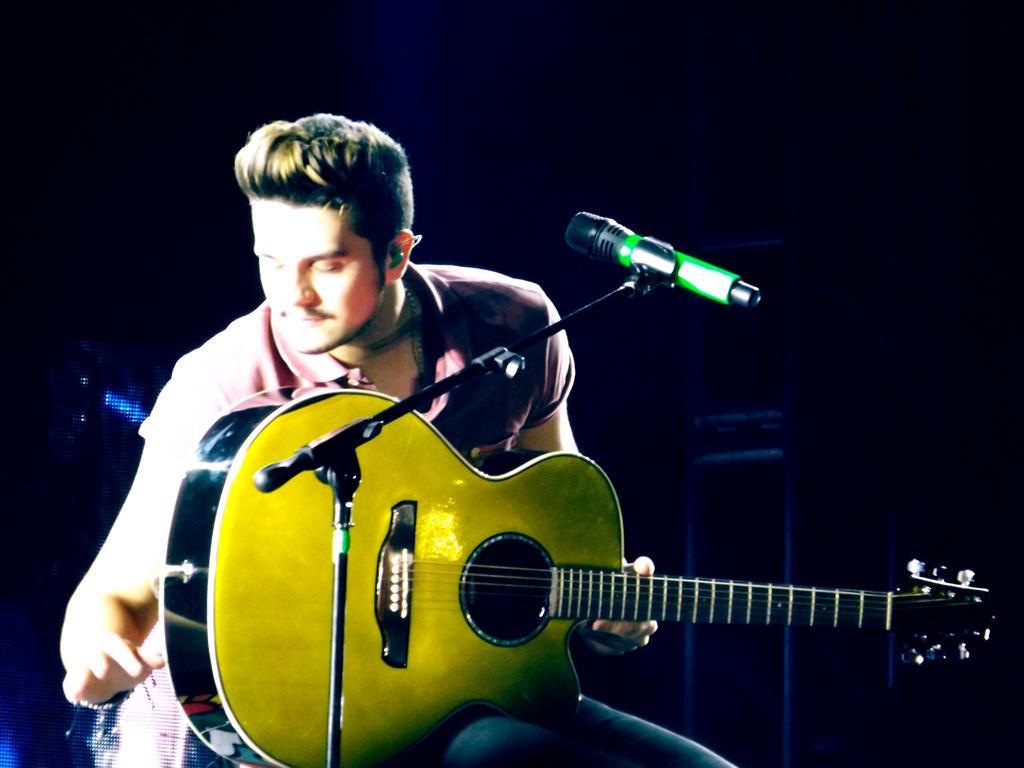How would you summarize this image in a sentence or two? In the center we can see one man sitting on chair and holding guitar. In front there is a microphone. In the background we can see few musical instruments. 